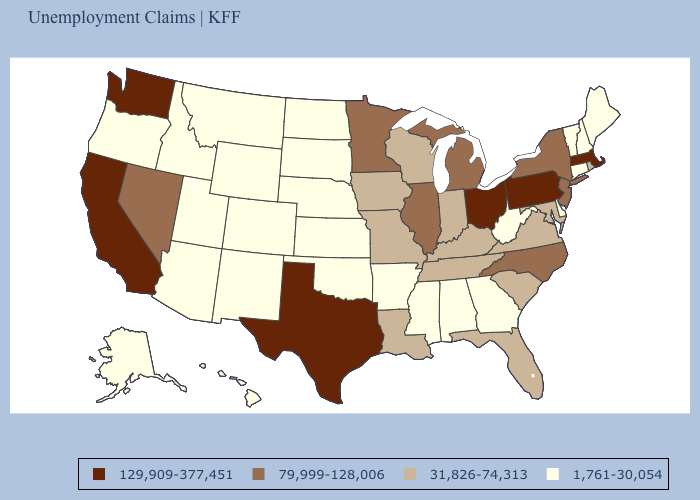What is the highest value in the USA?
Be succinct. 129,909-377,451. What is the lowest value in the MidWest?
Answer briefly. 1,761-30,054. Which states hav the highest value in the West?
Quick response, please. California, Washington. How many symbols are there in the legend?
Give a very brief answer. 4. What is the lowest value in states that border Florida?
Concise answer only. 1,761-30,054. Name the states that have a value in the range 31,826-74,313?
Give a very brief answer. Florida, Indiana, Iowa, Kentucky, Louisiana, Maryland, Missouri, Rhode Island, South Carolina, Tennessee, Virginia, Wisconsin. What is the value of Massachusetts?
Quick response, please. 129,909-377,451. Which states hav the highest value in the South?
Give a very brief answer. Texas. What is the value of Oregon?
Write a very short answer. 1,761-30,054. Does the map have missing data?
Be succinct. No. What is the highest value in states that border Arkansas?
Give a very brief answer. 129,909-377,451. Among the states that border Mississippi , which have the highest value?
Concise answer only. Louisiana, Tennessee. Which states hav the highest value in the South?
Answer briefly. Texas. Does Kansas have the lowest value in the MidWest?
Quick response, please. Yes. What is the lowest value in the Northeast?
Concise answer only. 1,761-30,054. 